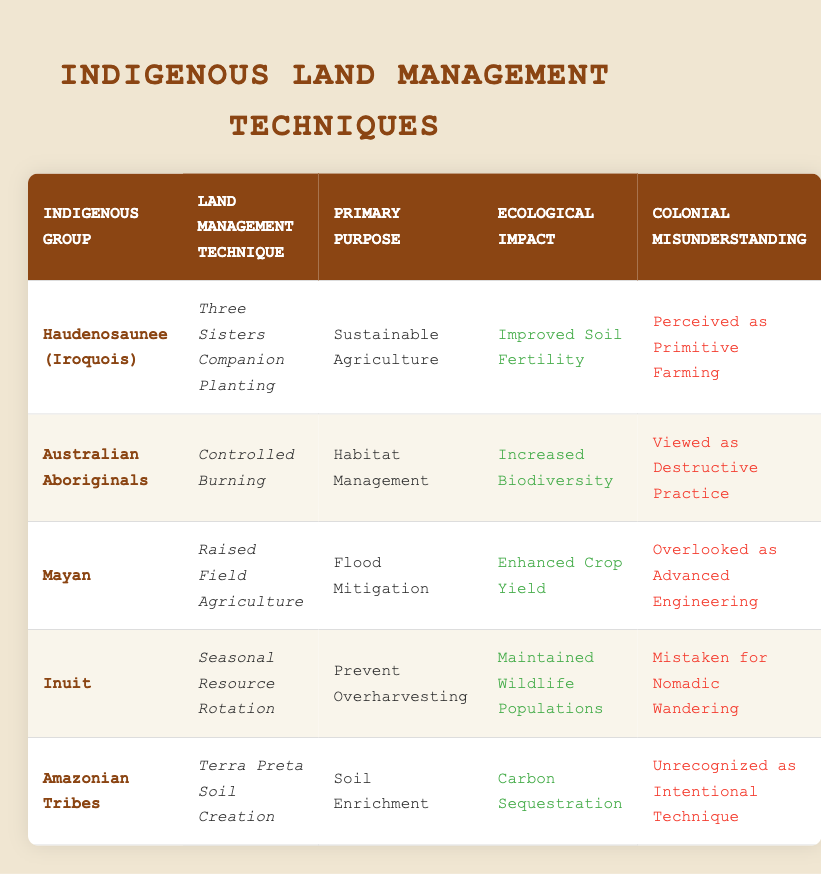What land management technique did the Haudenosaunee (Iroquois) use? The table lists "Three Sisters Companion Planting" as the land management technique for the Haudenosaunee. This information can be found directly in the row corresponding to this Indigenous group.
Answer: Three Sisters Companion Planting What was the primary purpose of Controlled Burning by Australian Aboriginals? According to the table, the primary purpose of Controlled Burning used by Australian Aboriginals is "Habitat Management." This is directly stated in the row related to this group.
Answer: Habitat Management Which Indigenous group practiced Raised Field Agriculture? The table indicates that the Mayan people practiced Raised Field Agriculture. This is clearly shown in the row designated for the Mayan group.
Answer: Mayan Is it true that all techniques listed had a colonial misunderstanding? Yes, every row includes a reference to a colonial misunderstanding, indicating that there was a perception problem regarding the techniques of each of the Indigenous groups.
Answer: Yes Which technique had the ecological impact of Increased Biodiversity? The ecological impact of Increased Biodiversity is attributed to the Controlled Burning technique practiced by Australian Aboriginals, as mentioned in their respective row.
Answer: Controlled Burning Which technique was used for flood mitigation and what was the resulting ecological impact? The technique used for flood mitigation is Raised Field Agriculture, which results in the ecological impact of Enhanced Crop Yield. This information can be obtained by looking up the Mayan in the table.
Answer: Raised Field Agriculture; Enhanced Crop Yield What is the average number of ecological impacts mentioned across all groups? There are 5 distinct ecological impacts listed (Improved Soil Fertility, Increased Biodiversity, Enhanced Crop Yield, Maintained Wildlife Populations, Carbon Sequestration). The average number is calculated by counting each distinct impact divided by the number of groups, which is 5/5 = 1 ecological impact on average.
Answer: 1 Which group focused on soil enrichment and what was their technique? The Amazonian Tribes focused on soil enrichment, and their technique was Terra Preta Soil Creation, as outlined in their row on the table.
Answer: Amazonian Tribes; Terra Preta Soil Creation What was a colonial misunderstanding regarding the Inuit's seasonal resource rotation? The table notes that the seasonal resource rotation practiced by the Inuit was mistaken for nomadic wandering, which is identified clearly in their row.
Answer: Mistaken for Nomadic Wandering 